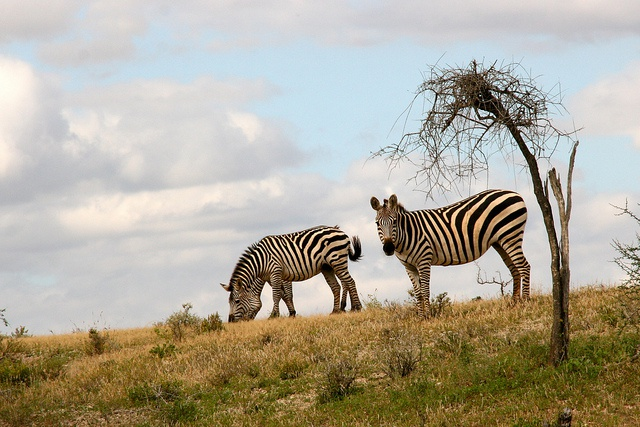Describe the objects in this image and their specific colors. I can see zebra in lightgray, black, maroon, and gray tones and zebra in lightgray, black, maroon, and gray tones in this image. 